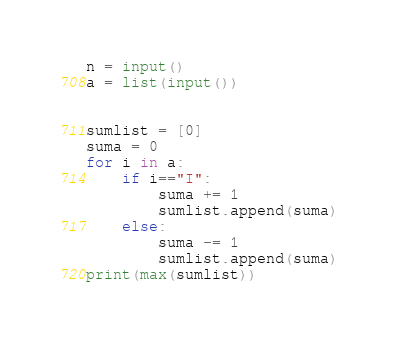Convert code to text. <code><loc_0><loc_0><loc_500><loc_500><_Python_>n = input()
a = list(input())


sumlist = [0]
suma = 0
for i in a:
    if i=="I":
        suma += 1
        sumlist.append(suma)
    else:
        suma -= 1
        sumlist.append(suma)
print(max(sumlist))</code> 